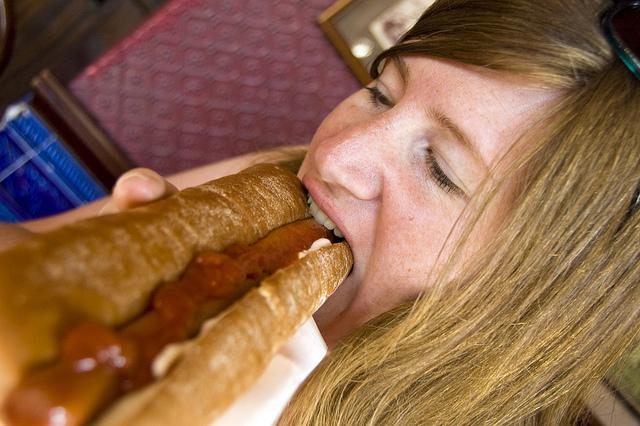Does the hotdog fit on the bun?
Short answer required. Yes. How many hot dog buns are in the picture?
Keep it brief. 1. What is the girl eating?
Give a very brief answer. Hot dog. Is the lady wearing glasses?
Give a very brief answer. No. What is the white topping on the hot dog?
Short answer required. Mayo. What is on top of the hot dog?
Quick response, please. Ketchup. 